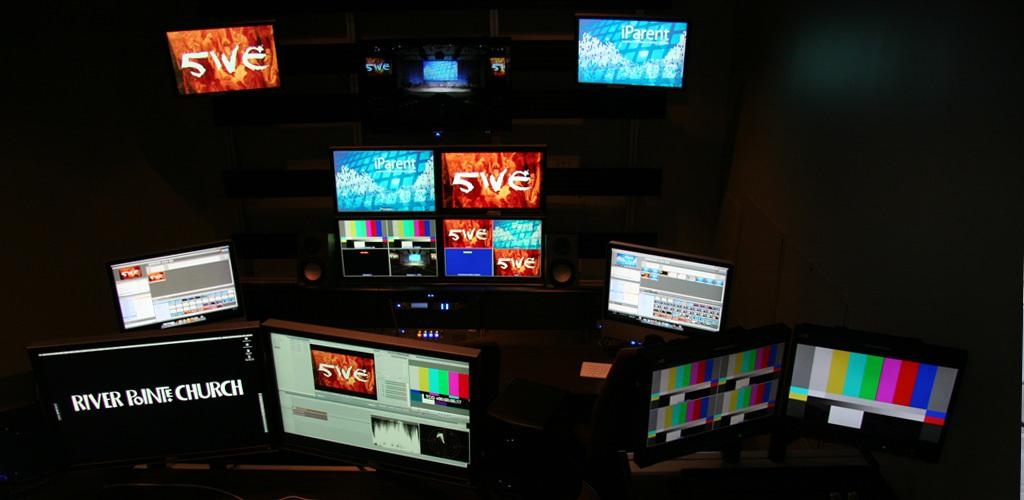<image>
Write a terse but informative summary of the picture. The monitor on the far left, and other monitors in the room, has an orange background with FIVE in white letters. 